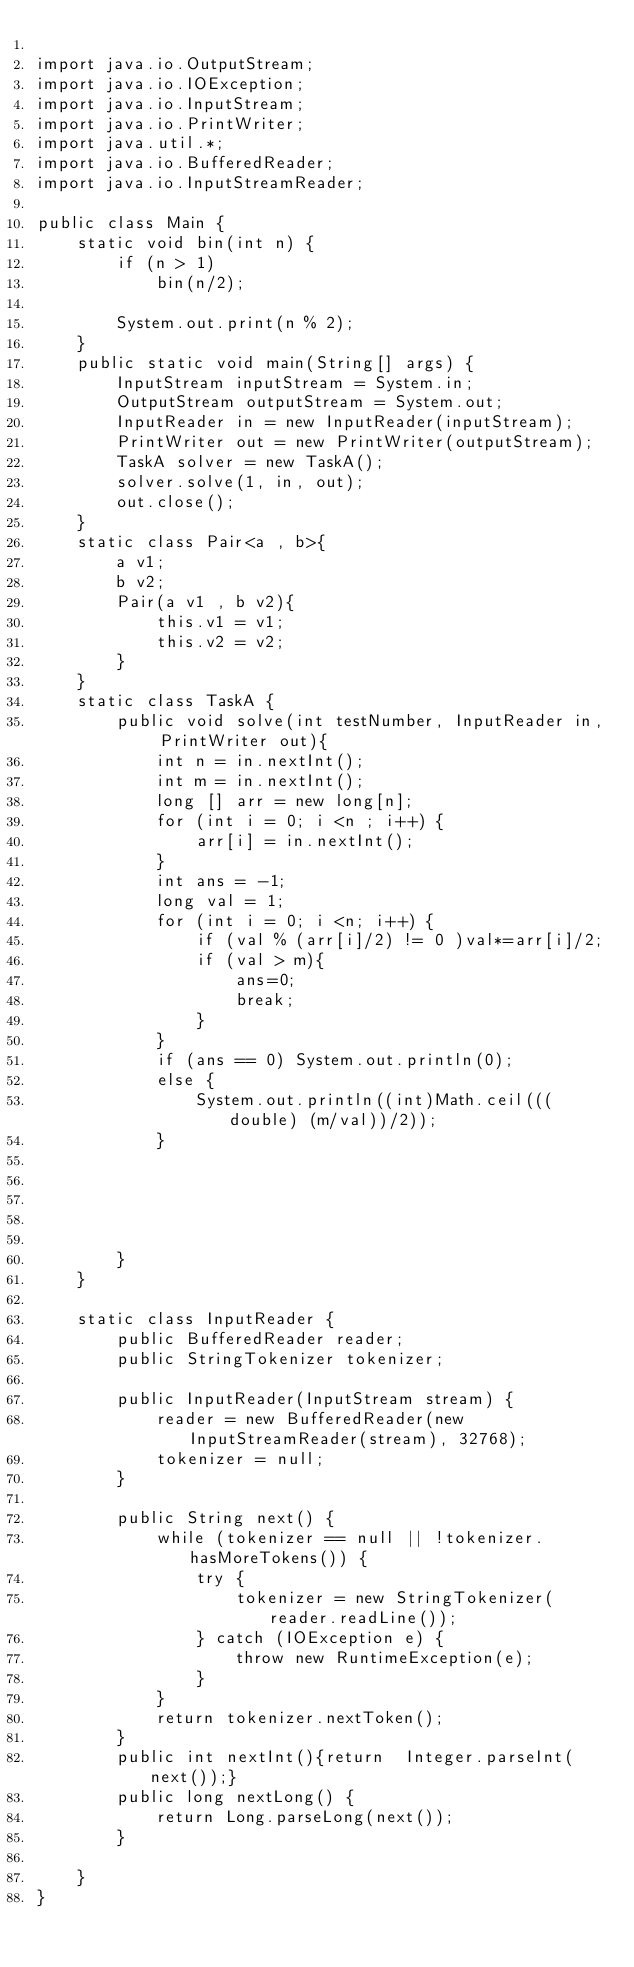Convert code to text. <code><loc_0><loc_0><loc_500><loc_500><_Java_>
import java.io.OutputStream;
import java.io.IOException;
import java.io.InputStream;
import java.io.PrintWriter;
import java.util.*;
import java.io.BufferedReader;
import java.io.InputStreamReader;

public class Main {
    static void bin(int n) {
        if (n > 1)
            bin(n/2);

        System.out.print(n % 2);
    }
    public static void main(String[] args) {
        InputStream inputStream = System.in;
        OutputStream outputStream = System.out;
        InputReader in = new InputReader(inputStream);
        PrintWriter out = new PrintWriter(outputStream);
        TaskA solver = new TaskA();
        solver.solve(1, in, out);
        out.close();
    }
    static class Pair<a , b>{
        a v1;
        b v2;
        Pair(a v1 , b v2){
            this.v1 = v1;
            this.v2 = v2;
        }
    }
    static class TaskA {
        public void solve(int testNumber, InputReader in, PrintWriter out){
            int n = in.nextInt();
            int m = in.nextInt();
            long [] arr = new long[n];
            for (int i = 0; i <n ; i++) {
                arr[i] = in.nextInt();
            }
            int ans = -1;
            long val = 1;
            for (int i = 0; i <n; i++) {
                if (val % (arr[i]/2) != 0 )val*=arr[i]/2;
                if (val > m){
                    ans=0;
                    break;
                }
            }
            if (ans == 0) System.out.println(0);
            else {
                System.out.println((int)Math.ceil(((double) (m/val))/2));
            }





        }
    }

    static class InputReader {
        public BufferedReader reader;
        public StringTokenizer tokenizer;

        public InputReader(InputStream stream) {
            reader = new BufferedReader(new InputStreamReader(stream), 32768);
            tokenizer = null;
        }

        public String next() {
            while (tokenizer == null || !tokenizer.hasMoreTokens()) {
                try {
                    tokenizer = new StringTokenizer(reader.readLine());
                } catch (IOException e) {
                    throw new RuntimeException(e);
                }
            }
            return tokenizer.nextToken();
        }
        public int nextInt(){return  Integer.parseInt(next());}
        public long nextLong() {
            return Long.parseLong(next());
        }

    }
}</code> 